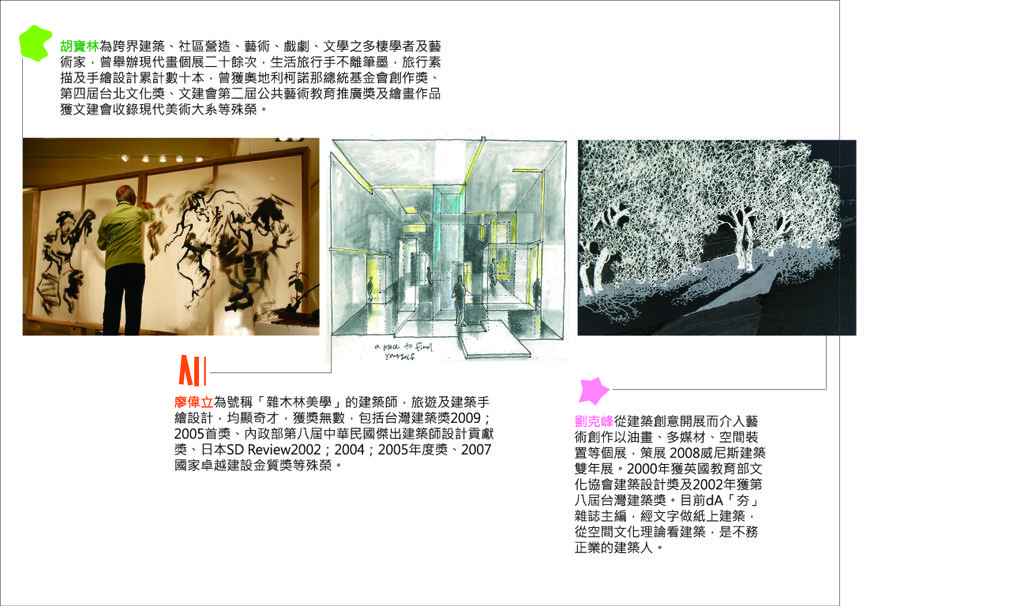How many pictures are present in the image? There are three pictures in the image. Are any of the pictures edited? Yes, two of the pictures are edited. Can you describe the person in the image? There is a person in the image, but no specific details about them are provided. What type of natural environment is visible in the image? There are trees in the image, which suggests a natural environment. What is the board used for in the image? The purpose of the board in the image is not specified. What type of lighting is present in the image? There are lights in the image, but no specific details about them are provided. What objects can be seen in the image? There are objects in the image, but no specific details about them are provided. How does the person in the image say good-bye to the trees? There is no indication in the image that the person is saying good-bye to the trees, as no interaction between them is depicted. What type of lead is used to connect the lights in the image? There is no mention of any leads or wires connecting the lights in the image, so it cannot be determined. 